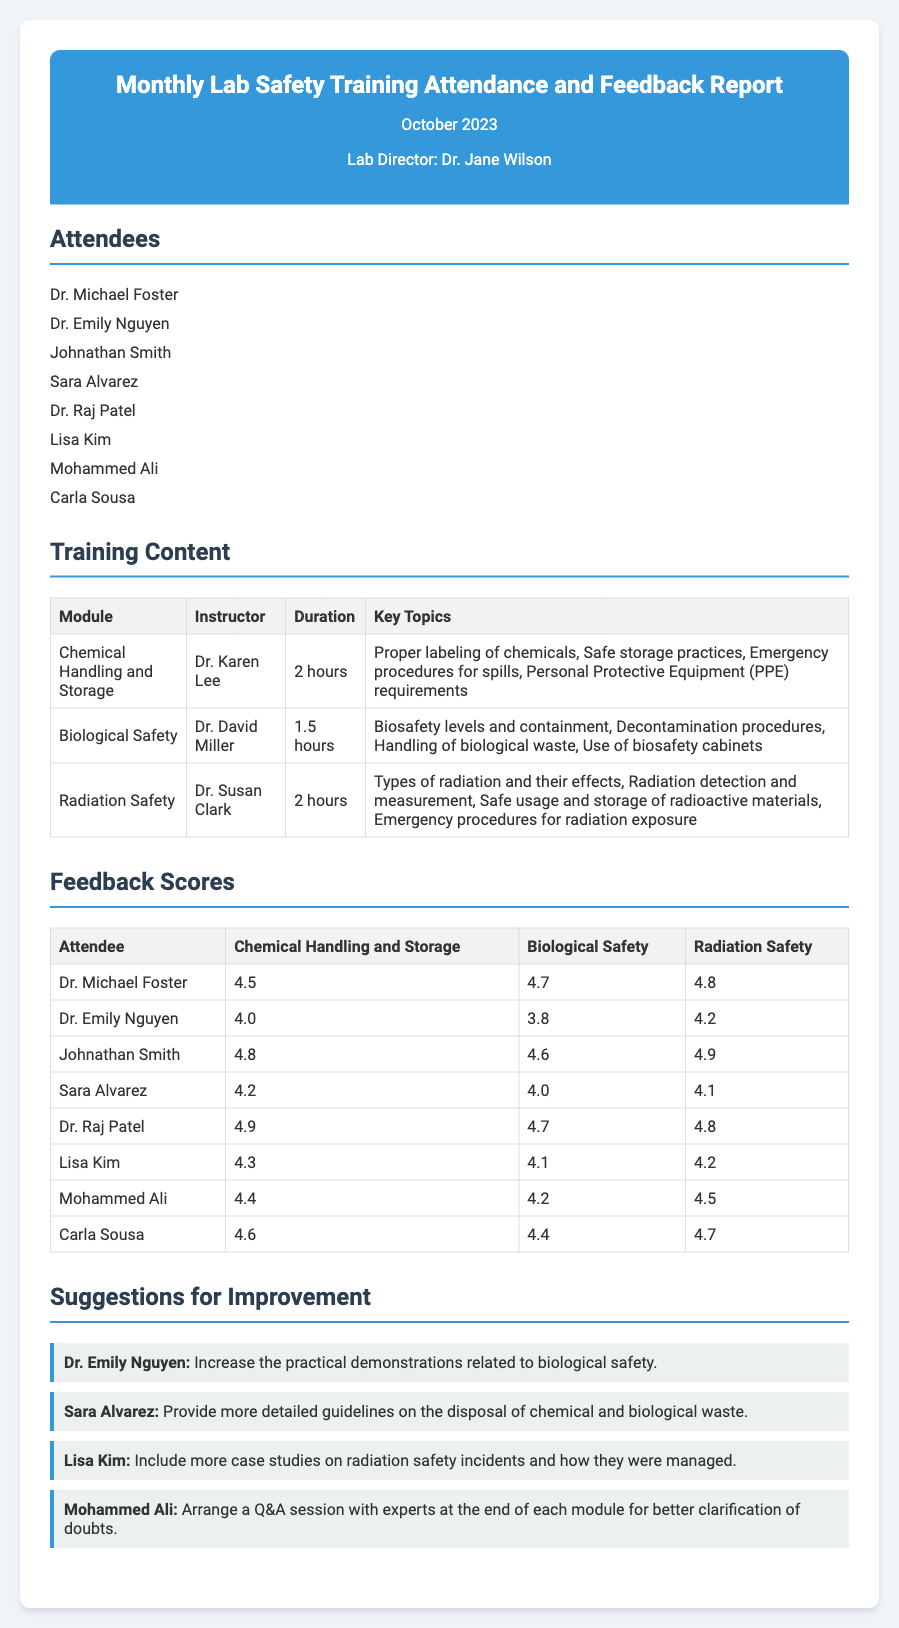What is the title of the report? The title is displayed prominently at the top of the report, indicating the content.
Answer: Monthly Lab Safety Training Attendance and Feedback Report Who conducted the training on Chemical Handling and Storage? The instructor for this module is mentioned in the training content section.
Answer: Dr. Karen Lee How many attendees were present at the training? The number of attendees is listed in the attendees section of the report.
Answer: 8 What was the feedback score given by Johnathan Smith for Biological Safety? This score is presented in the feedback scores section of the report.
Answer: 4.6 What suggestion did Mohammed Ali provide for improvement? Each suggestion is individually listed in the suggestions section of the report.
Answer: Arrange a Q&A session with experts at the end of each module for better clarification of doubts Which training module had the highest average feedback score? This requires calculating the average scores from the feedback scores table for all training modules.
Answer: Radiation Safety What is the duration of the Biological Safety training? The duration is specified in the training content section under the corresponding module.
Answer: 1.5 hours Who had the lowest feedback score for Chemical Handling and Storage? This can be determined by comparing scores in the feedback scores table.
Answer: Dr. Emily Nguyen 